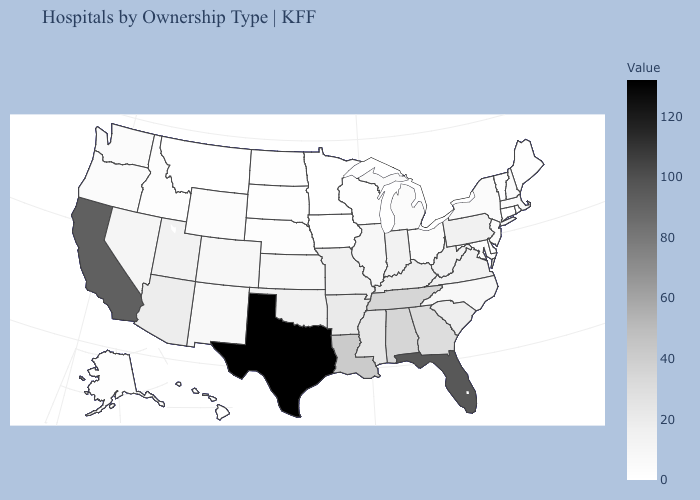Does Connecticut have the lowest value in the USA?
Quick response, please. Yes. Among the states that border Maine , which have the highest value?
Answer briefly. New Hampshire. Does Oregon have a lower value than Mississippi?
Quick response, please. Yes. Among the states that border West Virginia , which have the highest value?
Give a very brief answer. Kentucky. 